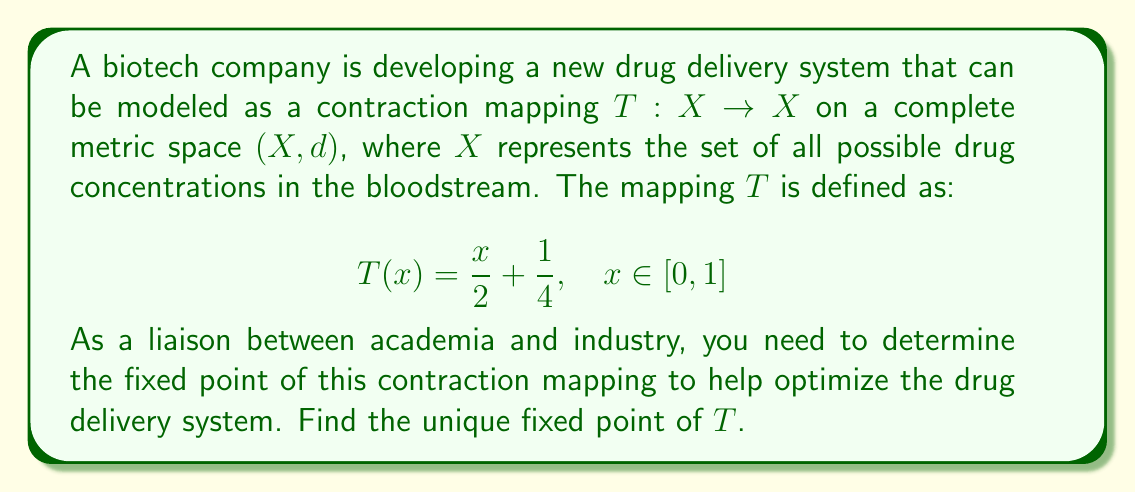Help me with this question. To find the fixed point of the contraction mapping $T$, we need to solve the equation $T(x) = x$. Let's approach this step-by-step:

1) The fixed point equation:
   $$T(x) = x$$
   $$\frac{x}{2} + \frac{1}{4} = x$$

2) Solve the equation:
   $$\frac{x}{2} + \frac{1}{4} = x$$
   $$\frac{x}{2} - x = -\frac{1}{4}$$
   $$-\frac{x}{2} = -\frac{1}{4}$$
   $$x = \frac{1}{2}$$

3) Verify that $T$ is indeed a contraction mapping:
   For any $x, y \in [0,1]$,
   $$|T(x) - T(y)| = \left|\frac{x}{2} + \frac{1}{4} - \frac{y}{2} - \frac{1}{4}\right| = \left|\frac{x-y}{2}\right| = \frac{1}{2}|x-y|$$

   Since $\frac{1}{2} < 1$, $T$ is a contraction mapping with Lipschitz constant $\frac{1}{2}$.

4) By the Banach Fixed-Point Theorem, since $T$ is a contraction mapping on the complete metric space $[0,1]$ with the usual metric, it has a unique fixed point.

Therefore, the unique fixed point of $T$ is $x = \frac{1}{2}$.
Answer: The unique fixed point of the contraction mapping $T(x) = \frac{x}{2} + \frac{1}{4}$ is $x = \frac{1}{2}$. 